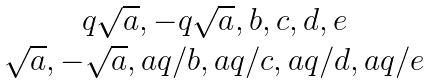<formula> <loc_0><loc_0><loc_500><loc_500>\begin{matrix} q \sqrt { a } , - q \sqrt { a } , b , c , d , e \\ \sqrt { a } , - \sqrt { a } , a q / b , a q / c , a q / d , a q / e \end{matrix}</formula> 